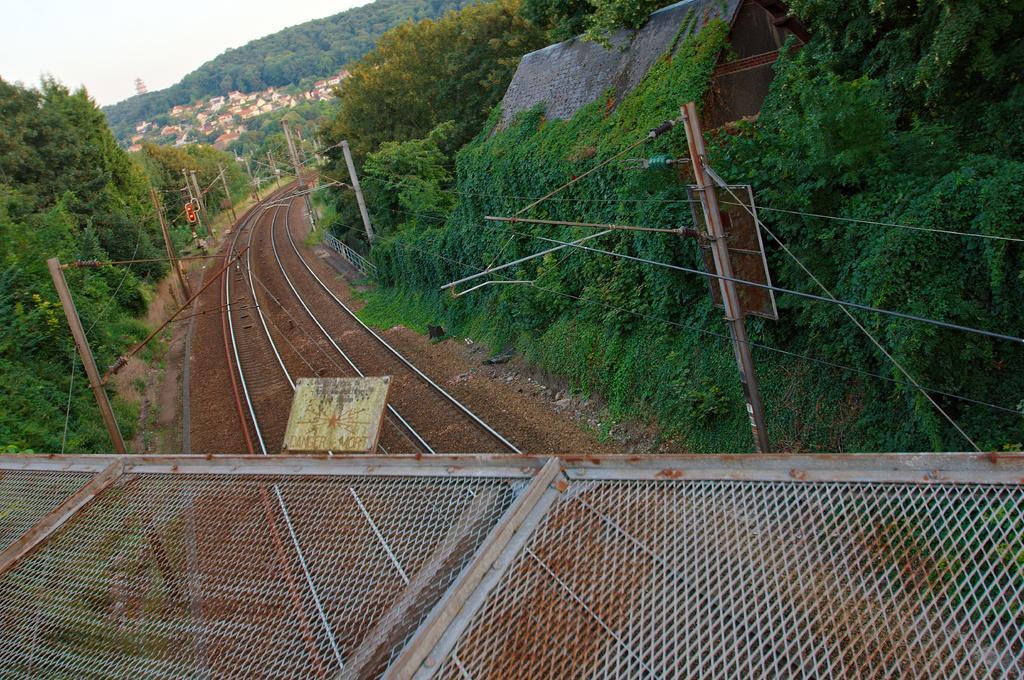Describe this image in one or two sentences. We can see mesh,tracks and poles with wires. Here we can see roof top and trees. In the background we can see trees,houses and sky. 